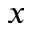<formula> <loc_0><loc_0><loc_500><loc_500>x</formula> 